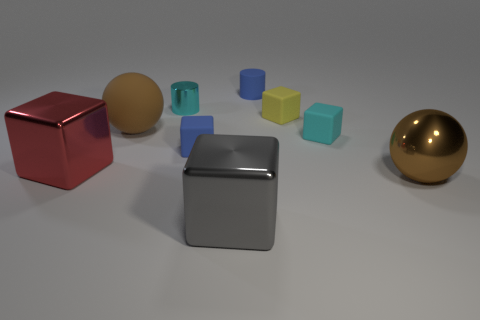What is the size of the object that is on the left side of the large gray metallic object and on the right side of the cyan metallic object?
Your answer should be compact. Small. Is the color of the rubber cylinder the same as the small cube that is on the left side of the large gray metal block?
Provide a short and direct response. Yes. Are there any purple metallic objects of the same shape as the cyan matte thing?
Provide a succinct answer. No. How many things are large metallic spheres or brown things that are on the right side of the rubber cylinder?
Offer a terse response. 1. How many other objects are there of the same material as the yellow thing?
Your response must be concise. 4. What number of things are metal balls or tiny metal cylinders?
Your response must be concise. 2. Are there more big red blocks that are to the right of the large red metal object than metal blocks in front of the big gray cube?
Offer a very short reply. No. Does the small block to the left of the rubber cylinder have the same color as the block in front of the red shiny object?
Ensure brevity in your answer.  No. What is the size of the brown sphere left of the brown metal object in front of the tiny blue object that is in front of the blue cylinder?
Provide a short and direct response. Large. There is another metallic object that is the same shape as the gray metallic thing; what is its color?
Offer a very short reply. Red. 